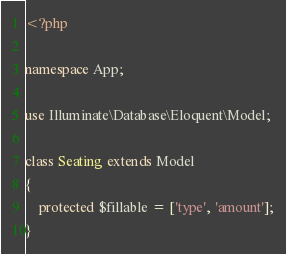<code> <loc_0><loc_0><loc_500><loc_500><_PHP_><?php

namespace App;

use Illuminate\Database\Eloquent\Model;

class Seating extends Model
{
    protected $fillable = ['type', 'amount'];
}
</code> 